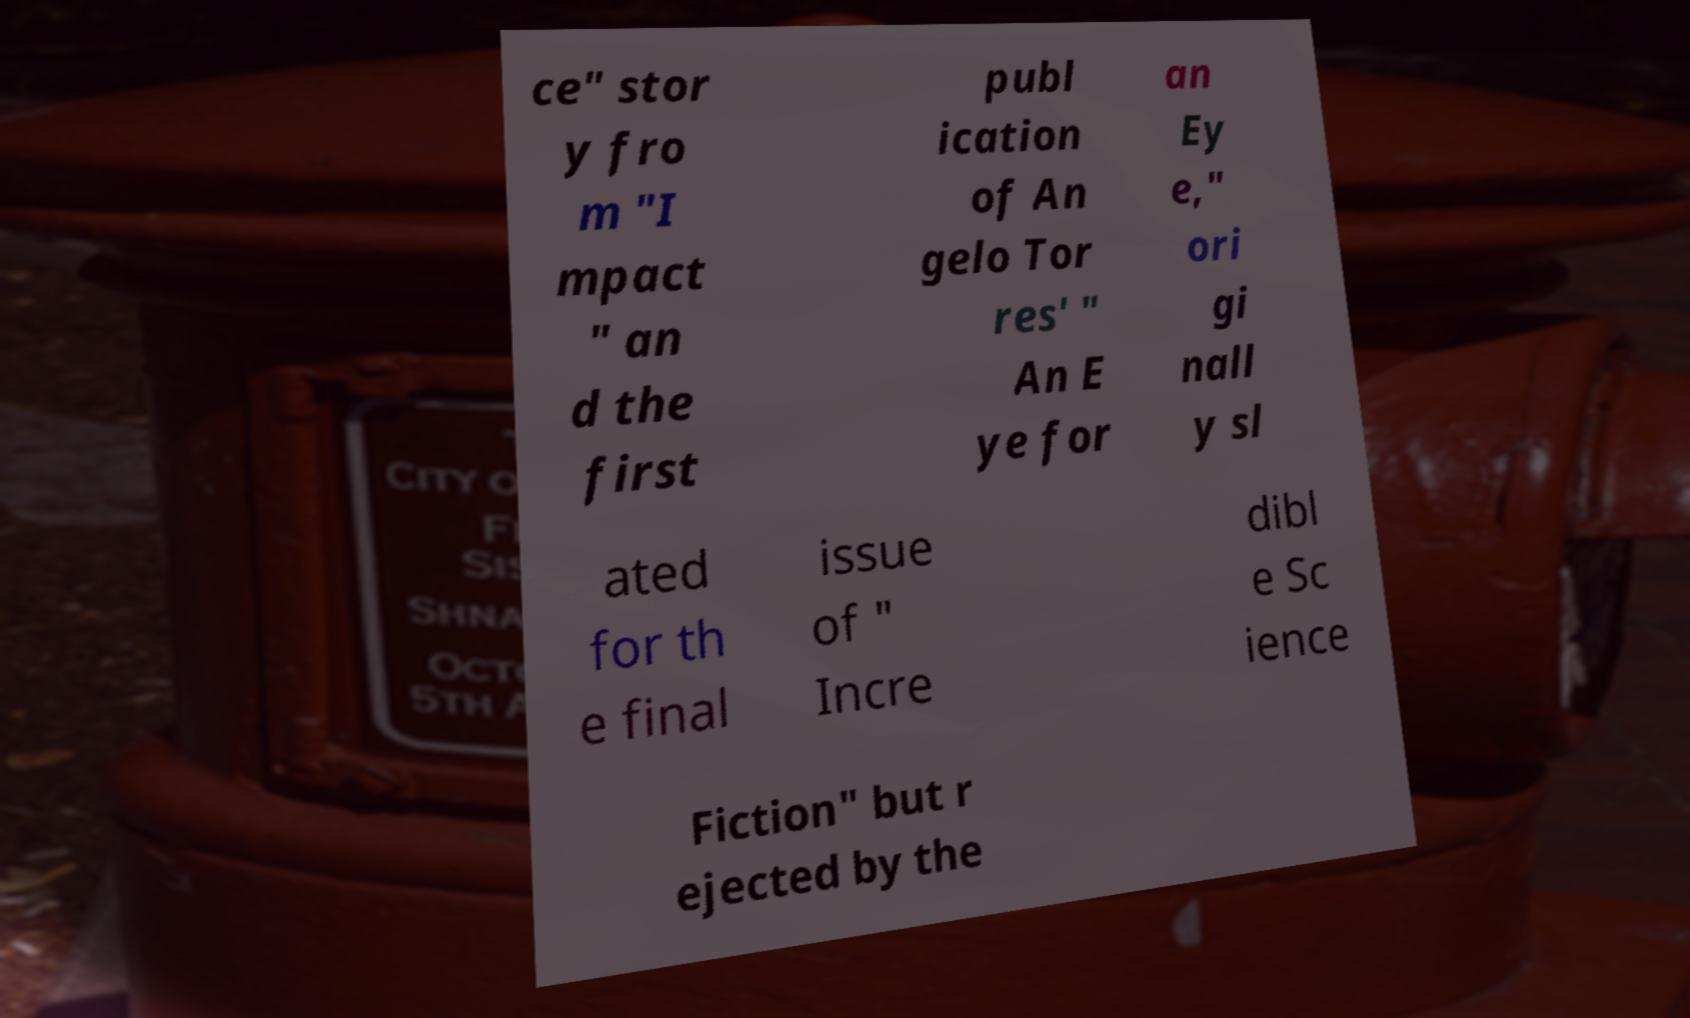I need the written content from this picture converted into text. Can you do that? ce" stor y fro m "I mpact " an d the first publ ication of An gelo Tor res' " An E ye for an Ey e," ori gi nall y sl ated for th e final issue of " Incre dibl e Sc ience Fiction" but r ejected by the 